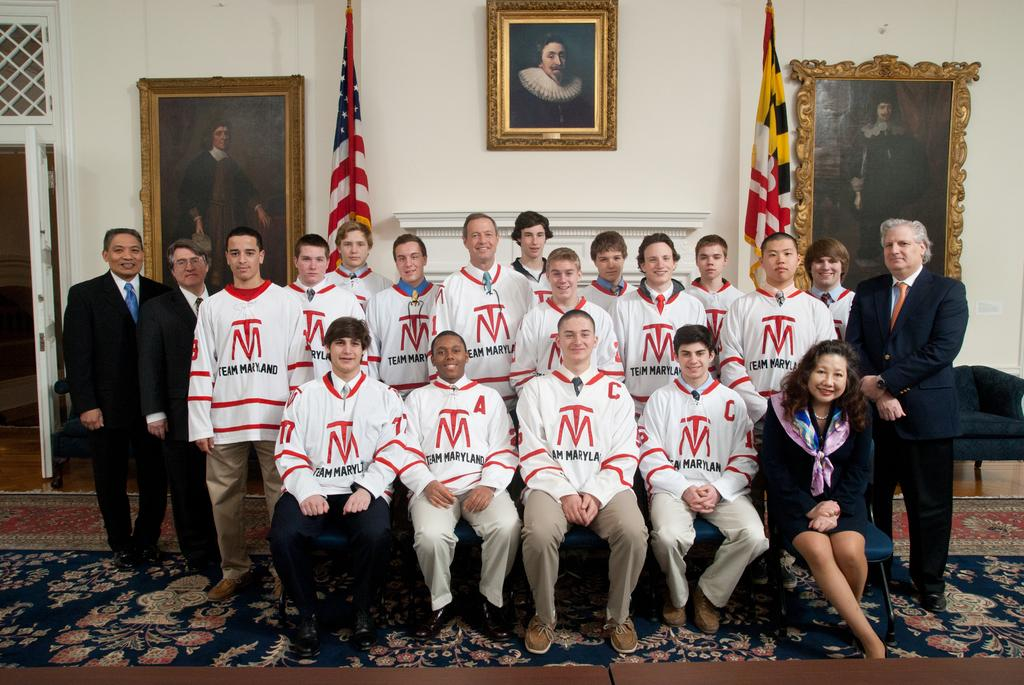<image>
Create a compact narrative representing the image presented. the letters TM that are on a shirt 